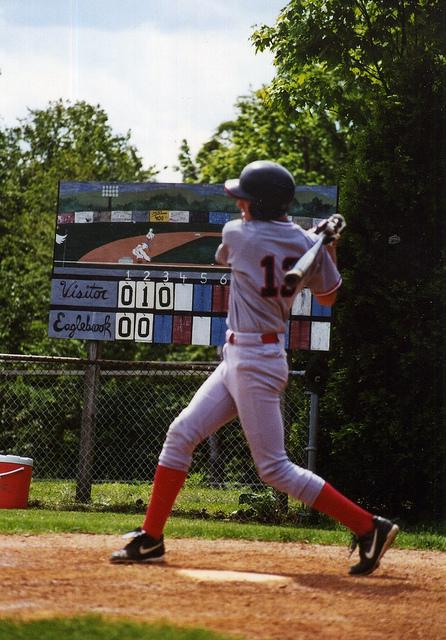Which team is winning? Please explain your reasoning. visitor. The score is 10 next to this one and it is 0 next to the home team 